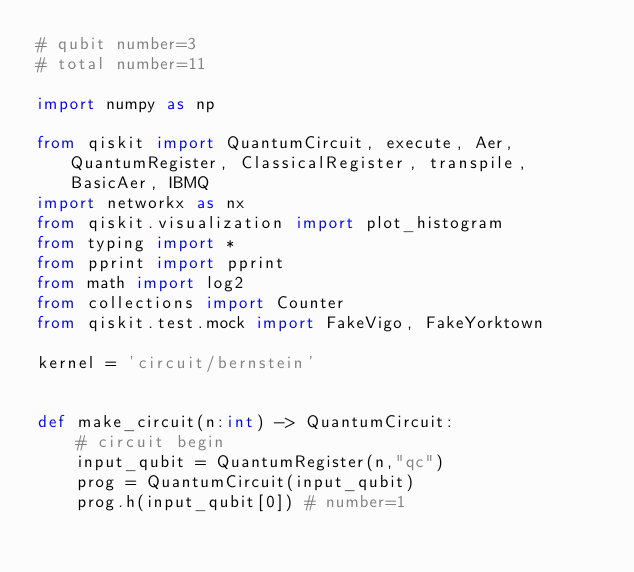<code> <loc_0><loc_0><loc_500><loc_500><_Python_># qubit number=3
# total number=11

import numpy as np

from qiskit import QuantumCircuit, execute, Aer, QuantumRegister, ClassicalRegister, transpile, BasicAer, IBMQ
import networkx as nx
from qiskit.visualization import plot_histogram
from typing import *
from pprint import pprint
from math import log2
from collections import Counter
from qiskit.test.mock import FakeVigo, FakeYorktown

kernel = 'circuit/bernstein'


def make_circuit(n:int) -> QuantumCircuit:
    # circuit begin
    input_qubit = QuantumRegister(n,"qc")
    prog = QuantumCircuit(input_qubit)
    prog.h(input_qubit[0]) # number=1</code> 